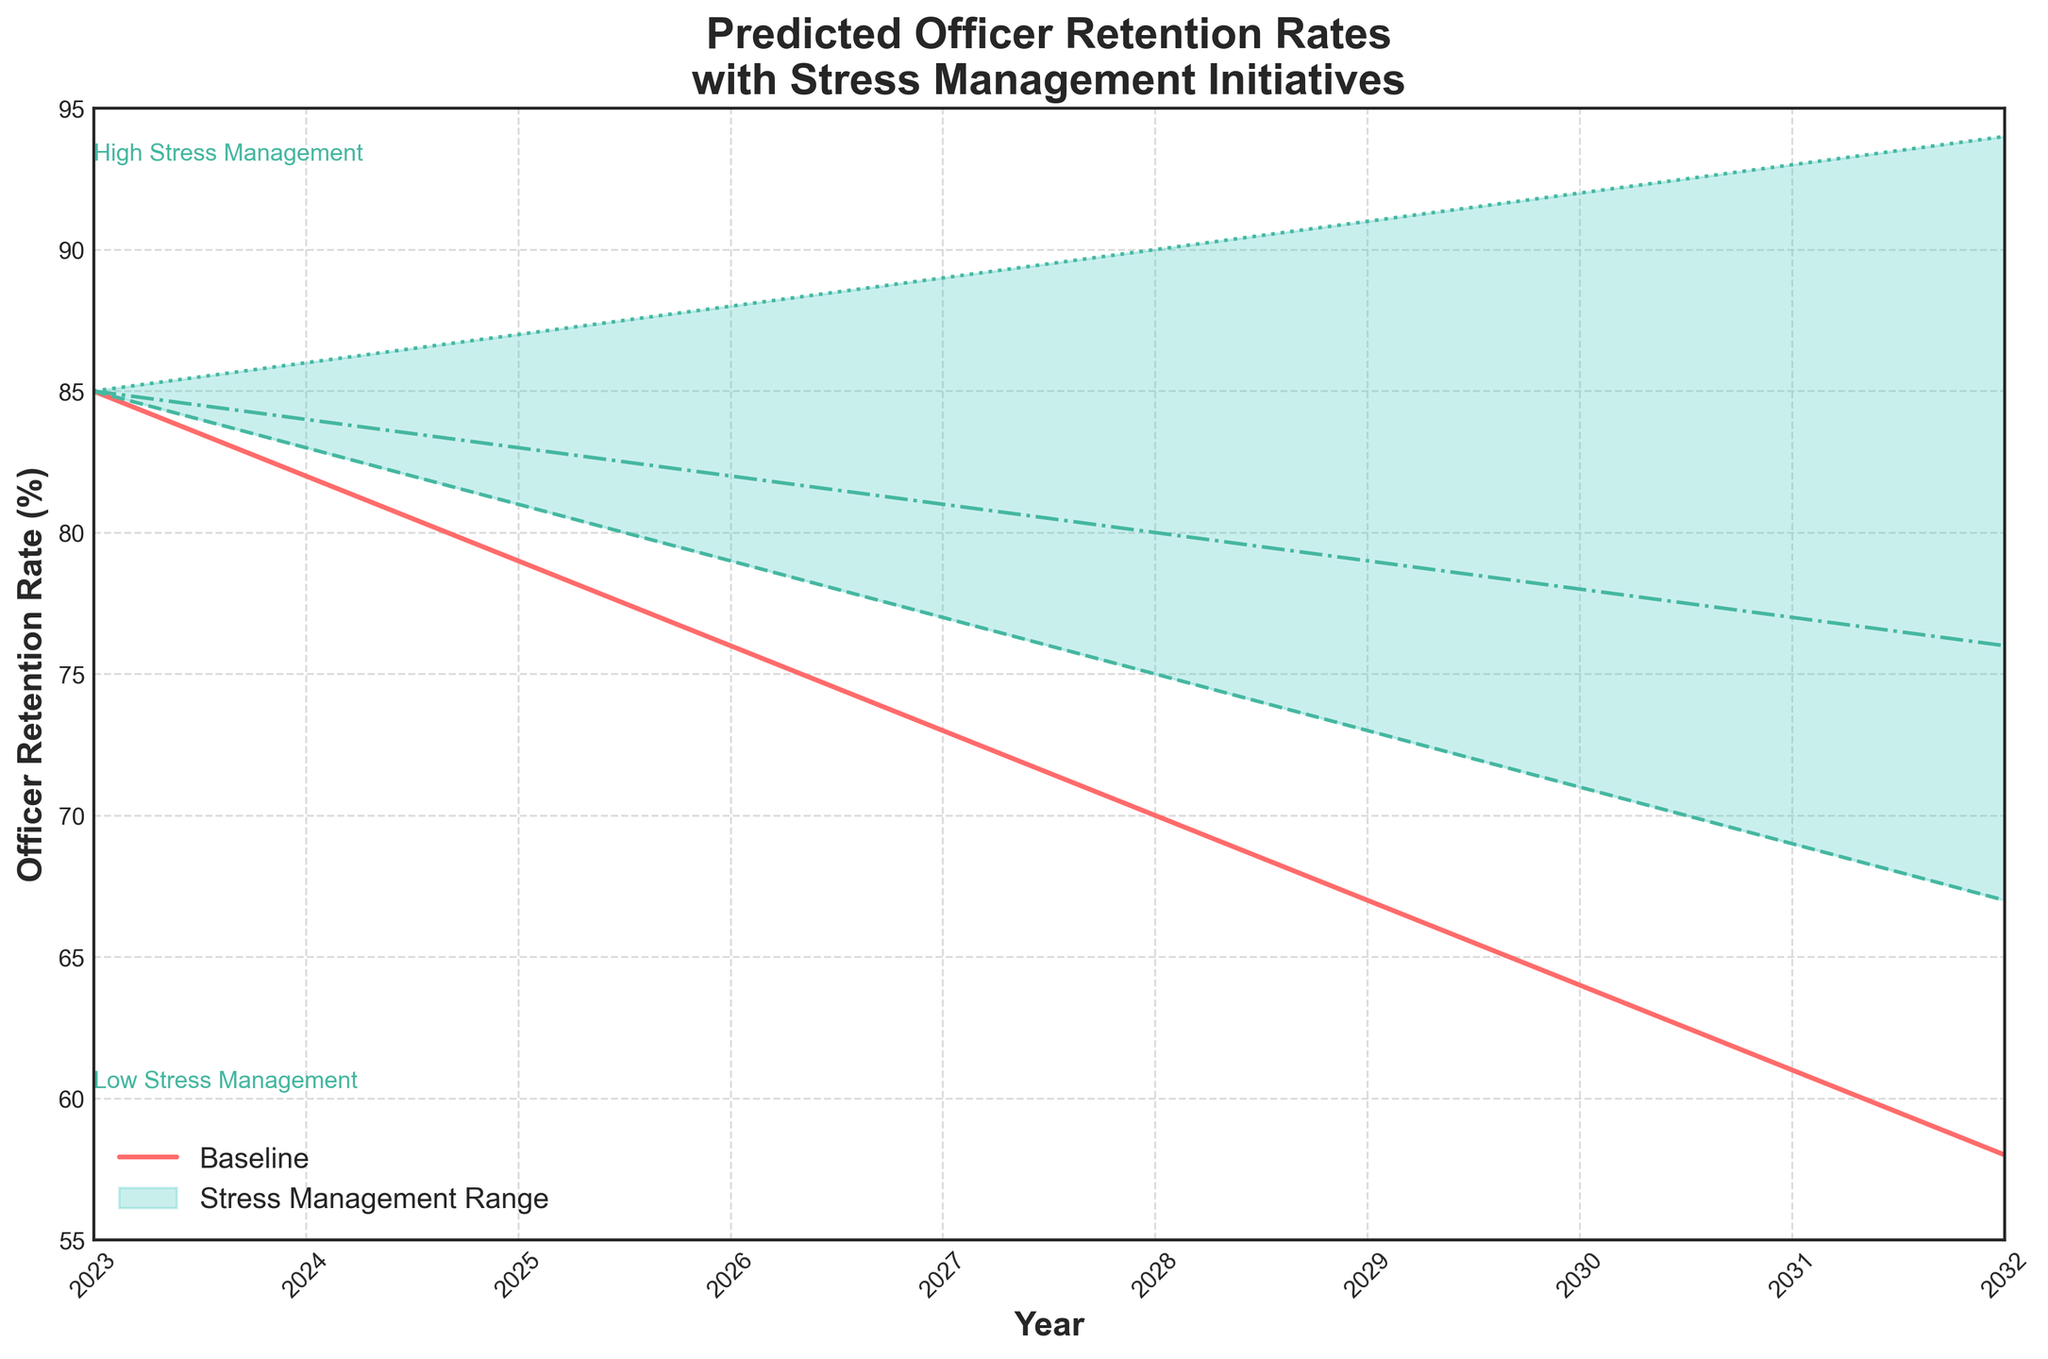What is the highest predicted officer retention rate in the year 2032? The highest retention rate in 2032 can be found in the "High Stress Management" scenario, which is the top of the filled area at that year.
Answer: 94% What is the overall trend of the baseline retention rate from 2023 to 2032? The baseline retention rate is represented by the main line in the plot. Observing this line from left to right, it shows a decreasing trend.
Answer: Decreasing What year shows the largest difference between the baseline and high stress management retention rates? To determine this, find the year with the greatest vertical distance between the baseline line and the top line of the fan chart (high stress management). In 2032, the baseline is at 58% while high stress management is at 94%, making the difference 36%.
Answer: 2032 How does the medium stress management retention rate trend from 2023 to 2032? The medium stress management retention rate is denoted by the dot-dashed line. Observing this line from 2023 to 2032, it shows an increasing trend.
Answer: Increasing What is the predicted retention rate for officers in 2026 given medium stress management initiatives? Locate the dot-dashed line for medium stress management at the year 2026. The corresponding value is 82%.
Answer: 82% Which stress management level shows the steadiest year-over-year decline in retention rate? The baseline (no stress management) shows the steadiest year-over-year decline, as indicated by the solid red line that continues to decrease steadily over the years.
Answer: Baseline How much higher is the high stress management retention rate compared to the low stress management retention rate in 2028? In 2028, find the retention rates for both the high and low stress management lines. High is at 90%, low is at 75%. The difference is 90% - 75% = 15%.
Answer: 15% What is the difference in predicted retention rates between low and medium stress management in 2030? For the year 2030, find the retention rates for low (dashed line) and medium (dot-dashed line). Low is at 71%, medium is at 78%. The difference is 78% - 71% = 7%.
Answer: 7% What is the retention rate range predicted for the year 2029? The retention rate range can be found between the low and high stress management values for 2029. Low is at 73%, high is at 91%. The range is from 73% to 91%.
Answer: 73% to 91% 